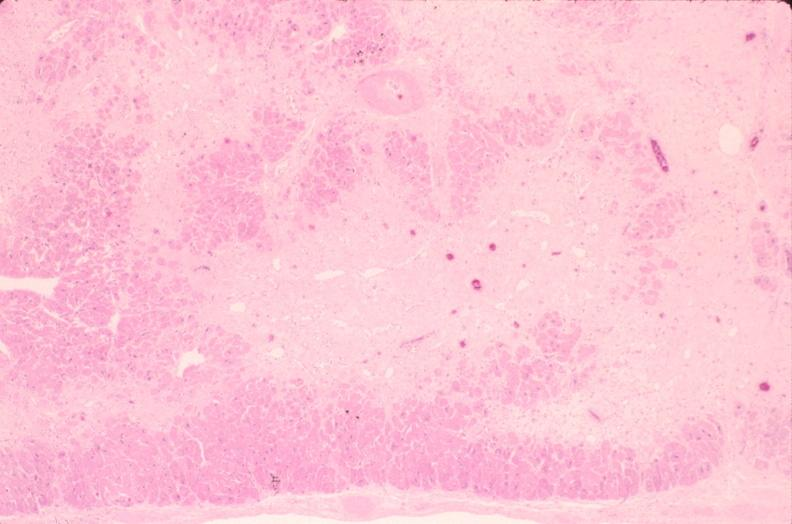what does this image show?
Answer the question using a single word or phrase. Heart 